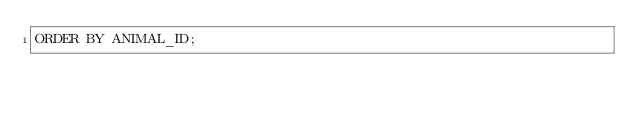<code> <loc_0><loc_0><loc_500><loc_500><_SQL_>ORDER BY ANIMAL_ID;</code> 